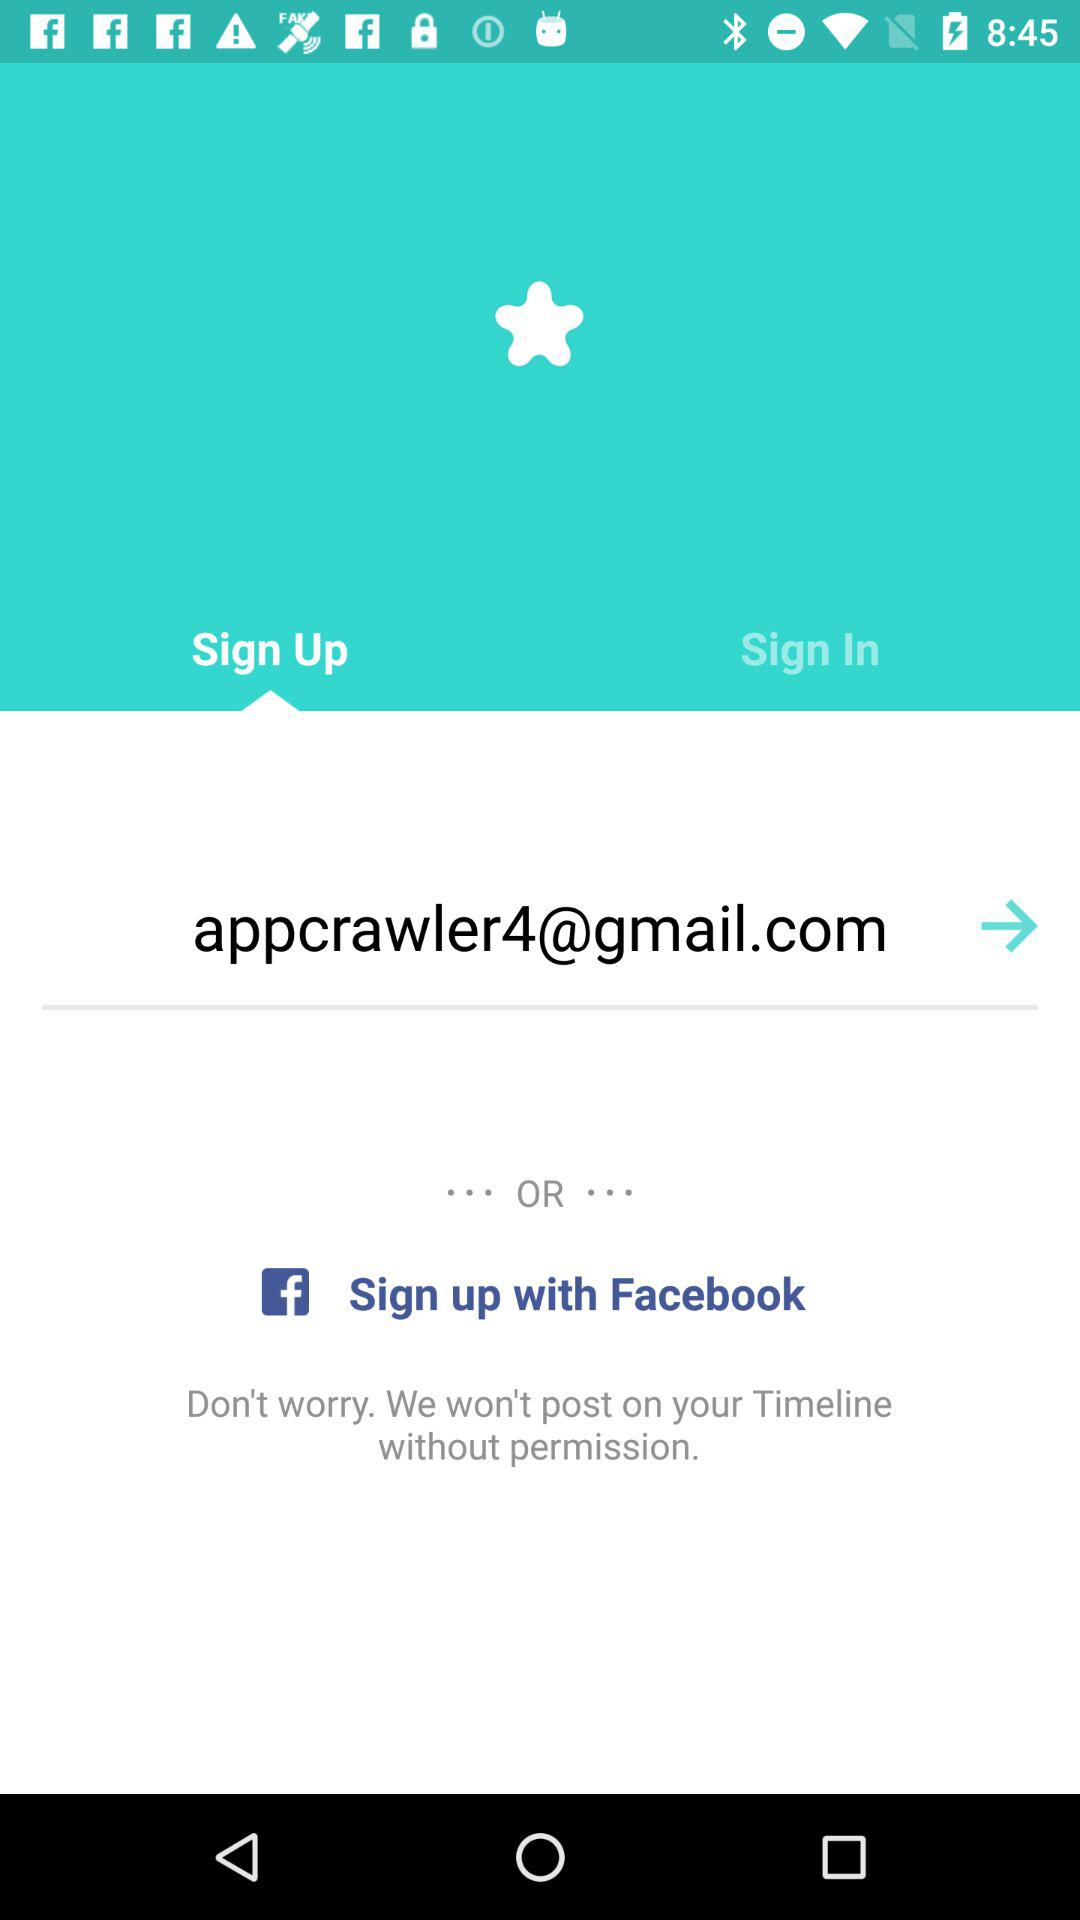What is the login id? The login id is appcrawler4@gmail.com. 